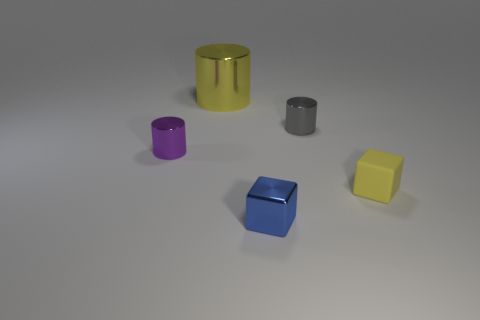Does the tiny block right of the blue shiny cube have the same material as the large object?
Your answer should be compact. No. What shape is the purple object that is the same size as the shiny cube?
Provide a succinct answer. Cylinder. What number of big metal cylinders have the same color as the rubber block?
Provide a succinct answer. 1. Are there fewer blue shiny objects in front of the purple shiny thing than small cylinders that are behind the big metallic cylinder?
Provide a short and direct response. No. Are there any big yellow things in front of the small purple metal cylinder?
Your answer should be compact. No. There is a yellow object behind the small metal cylinder left of the yellow metal thing; is there a small gray metallic object on the left side of it?
Ensure brevity in your answer.  No. There is a metallic object that is on the right side of the shiny block; does it have the same shape as the blue thing?
Ensure brevity in your answer.  No. What color is the cube that is made of the same material as the small gray cylinder?
Your answer should be very brief. Blue. How many yellow cubes have the same material as the large yellow object?
Offer a very short reply. 0. What color is the block that is to the left of the tiny thing right of the small cylinder that is behind the purple thing?
Provide a short and direct response. Blue. 